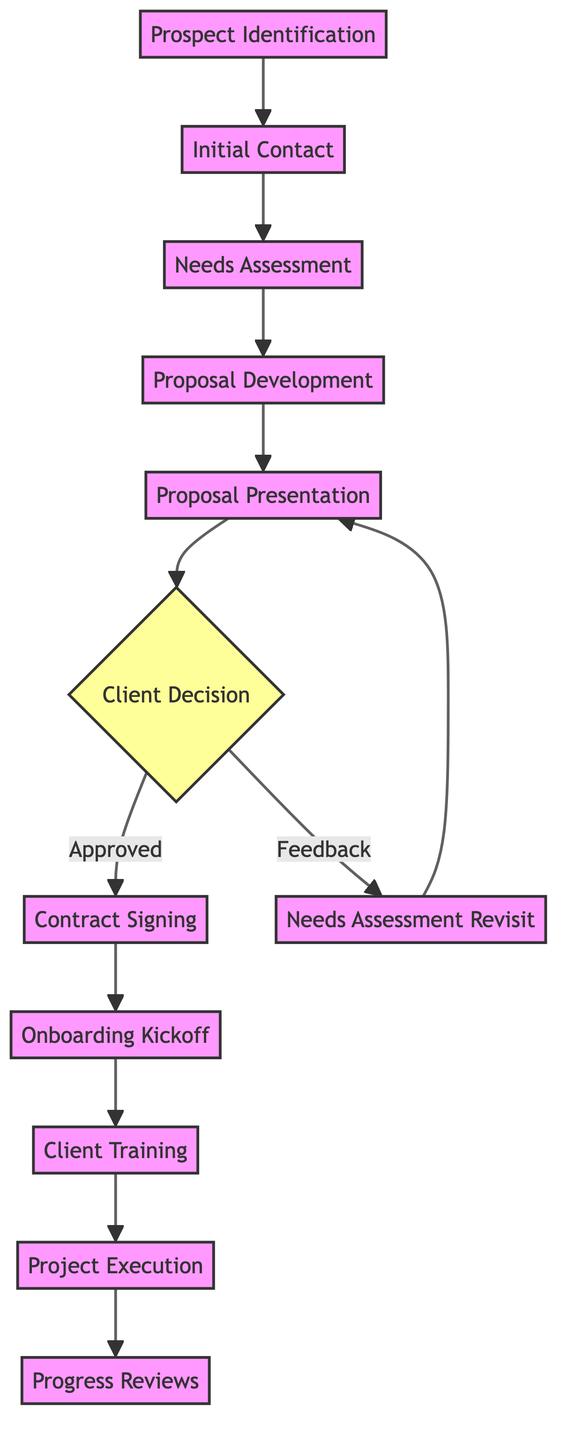What is the first step in the onboarding process? The first step provided in the diagram is "Prospect Identification," which denotes the initiation of the onboarding process by identifying potential clients.
Answer: Prospect Identification How many steps are there in total in the client onboarding process? Counting the nodes in the diagram, there are a total of 12 steps from "Prospect Identification" to "Progress Reviews."
Answer: 12 What happens after the "Proposal Presentation"? According to the diagram, after the "Proposal Presentation," there is a decision point called "Client Decision," where the client reviews the proposal.
Answer: Client Decision What is the next step after "Needs Assessment Revisit"? The flow demonstrates that after the "Needs Assessment Revisit," the next step is "Proposal Presentation," indicating that revisiting leads back to presenting the proposal again.
Answer: Proposal Presentation Which step directly follows "Contract Signing"? Following "Contract Signing," the process continues to "Onboarding Kickoff," marking the transition to initiating the onboarding process after the contract is finalized.
Answer: Onboarding Kickoff What are the two possible outcomes after "Client Decision"? The two possible outcomes outlined in the diagram are "Contract Signing" if approved or "Needs Assessment Revisit" if feedback is provided, demonstrating the decision point's bifurcation.
Answer: Contract Signing, Needs Assessment Revisit What is the final step of the onboarding process? The final step in the onboarding process as depicted in the diagram is "Progress Reviews," which involves ongoing evaluation of the project with the client.
Answer: Progress Reviews How do you progress from "Client Training" to the final step? The transition from "Client Training" to the final step "Project Execution" is direct, indicating that after training, the project will commence based on the agreed proposal.
Answer: Project Execution What does the "Client Decision" node represent? The "Client Decision" node represents a critical moment where the client reviews the proposal and decides whether to proceed with the contract or provide feedback, marking a decisive point in the process.
Answer: Client Decision 